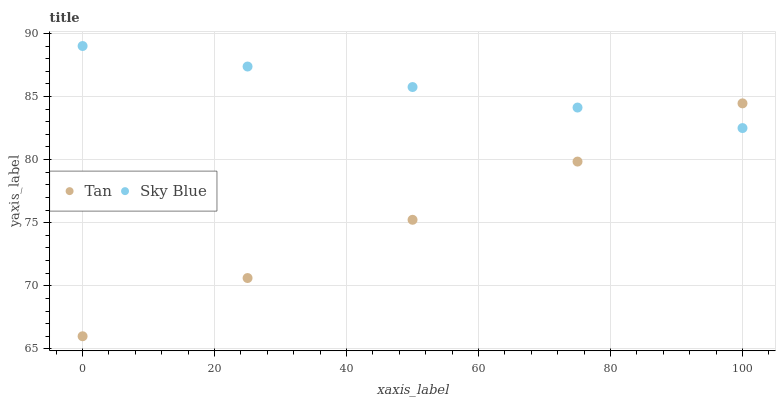Does Tan have the minimum area under the curve?
Answer yes or no. Yes. Does Sky Blue have the maximum area under the curve?
Answer yes or no. Yes. Does Tan have the maximum area under the curve?
Answer yes or no. No. Is Tan the smoothest?
Answer yes or no. Yes. Is Sky Blue the roughest?
Answer yes or no. Yes. Is Tan the roughest?
Answer yes or no. No. Does Tan have the lowest value?
Answer yes or no. Yes. Does Sky Blue have the highest value?
Answer yes or no. Yes. Does Tan have the highest value?
Answer yes or no. No. Does Sky Blue intersect Tan?
Answer yes or no. Yes. Is Sky Blue less than Tan?
Answer yes or no. No. Is Sky Blue greater than Tan?
Answer yes or no. No. 